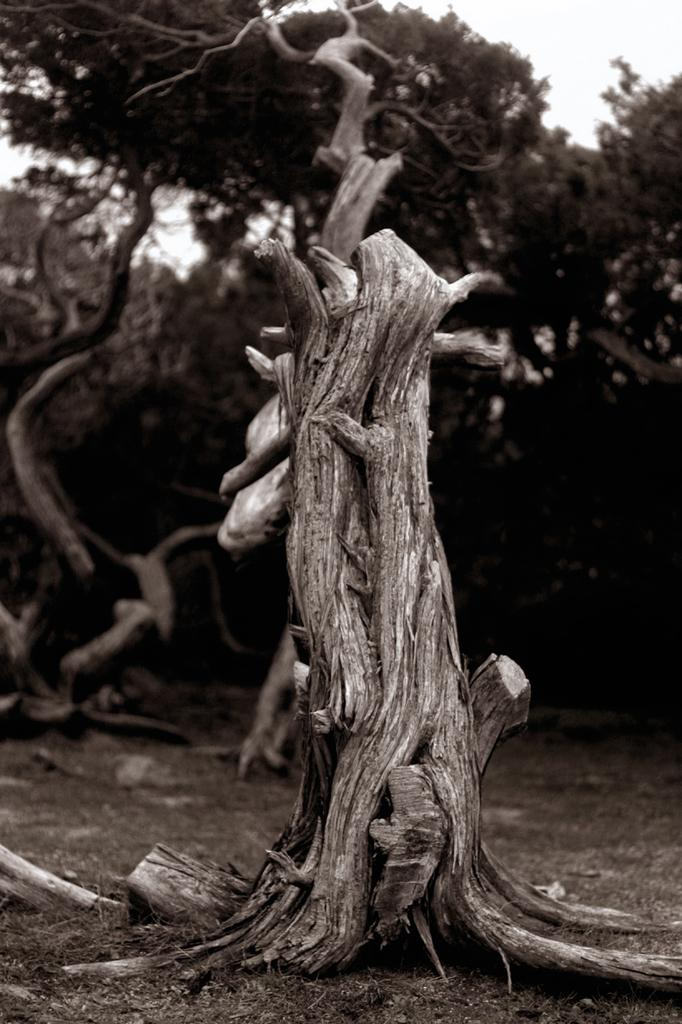What is the main subject in the foreground of the image? There is a tree trunk in the foreground of the image. What can be seen in the background of the image? There are trees visible in the background of the image. Where is the boot placed on the shelf in the image? There is no boot or shelf present in the image; it only features a tree trunk in the foreground and trees in the background. 